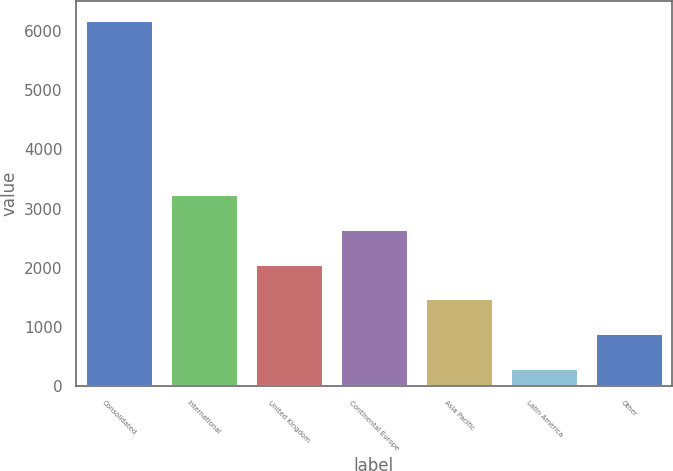<chart> <loc_0><loc_0><loc_500><loc_500><bar_chart><fcel>Consolidated<fcel>International<fcel>United Kingdom<fcel>Continental Europe<fcel>Asia Pacific<fcel>Latin America<fcel>Other<nl><fcel>6190.8<fcel>3247.1<fcel>2069.62<fcel>2658.36<fcel>1480.88<fcel>303.4<fcel>892.14<nl></chart> 